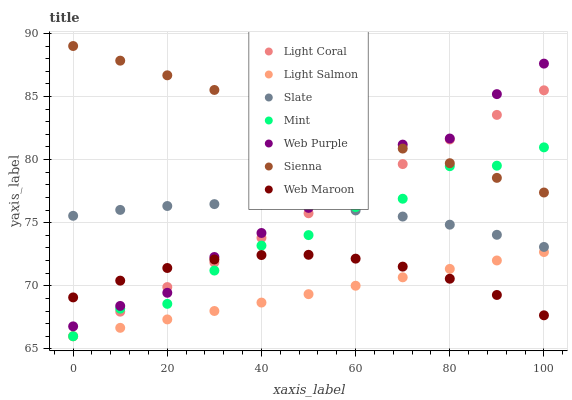Does Light Salmon have the minimum area under the curve?
Answer yes or no. Yes. Does Sienna have the maximum area under the curve?
Answer yes or no. Yes. Does Slate have the minimum area under the curve?
Answer yes or no. No. Does Slate have the maximum area under the curve?
Answer yes or no. No. Is Light Salmon the smoothest?
Answer yes or no. Yes. Is Mint the roughest?
Answer yes or no. Yes. Is Slate the smoothest?
Answer yes or no. No. Is Slate the roughest?
Answer yes or no. No. Does Light Salmon have the lowest value?
Answer yes or no. Yes. Does Slate have the lowest value?
Answer yes or no. No. Does Sienna have the highest value?
Answer yes or no. Yes. Does Light Salmon have the highest value?
Answer yes or no. No. Is Light Salmon less than Sienna?
Answer yes or no. Yes. Is Slate greater than Web Maroon?
Answer yes or no. Yes. Does Mint intersect Slate?
Answer yes or no. Yes. Is Mint less than Slate?
Answer yes or no. No. Is Mint greater than Slate?
Answer yes or no. No. Does Light Salmon intersect Sienna?
Answer yes or no. No. 